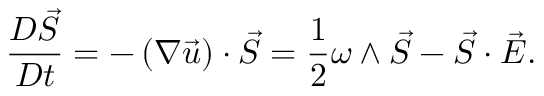Convert formula to latex. <formula><loc_0><loc_0><loc_500><loc_500>\frac { D \vec { S } } { D t } = - \left ( \nabla \vec { u } \right ) \cdot \vec { S } = \frac { 1 } { 2 } \omega \wedge \vec { S } - \vec { S } \cdot \vec { E } .</formula> 